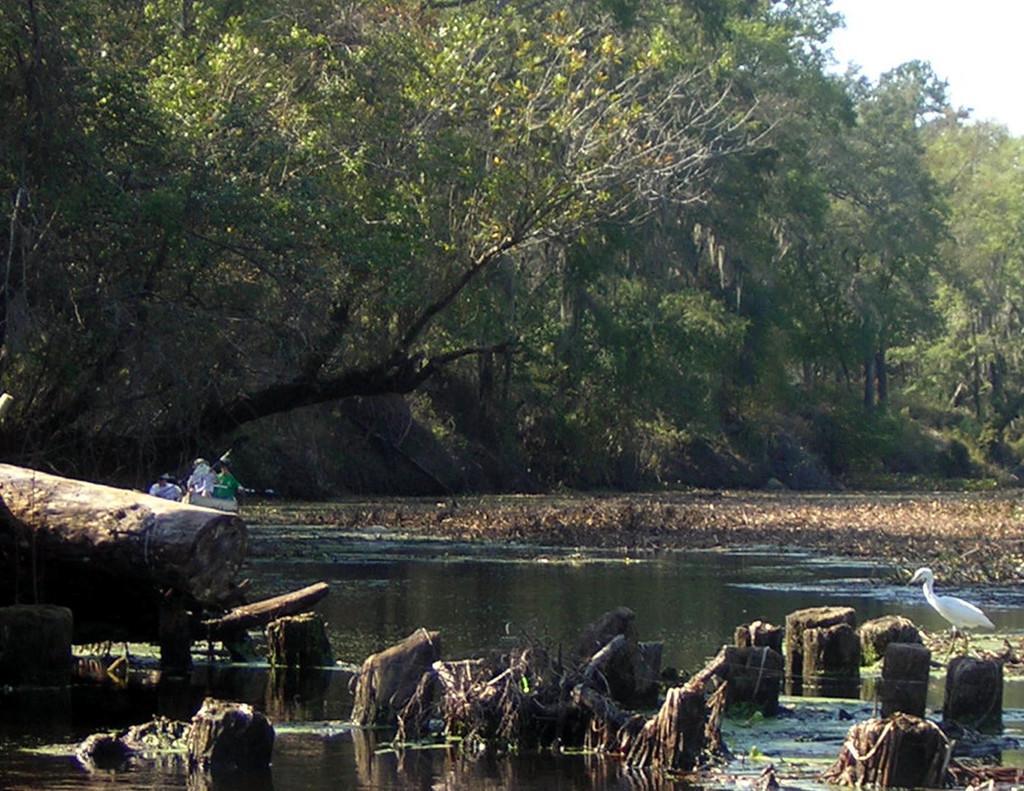Please provide a concise description of this image. This is the picture of a river. In this image there are group of people sitting on the boat and there is a boat on the water. At the back there are trees. In the foreground there is a crane. At the top there is sky. At the bottom there is water. 